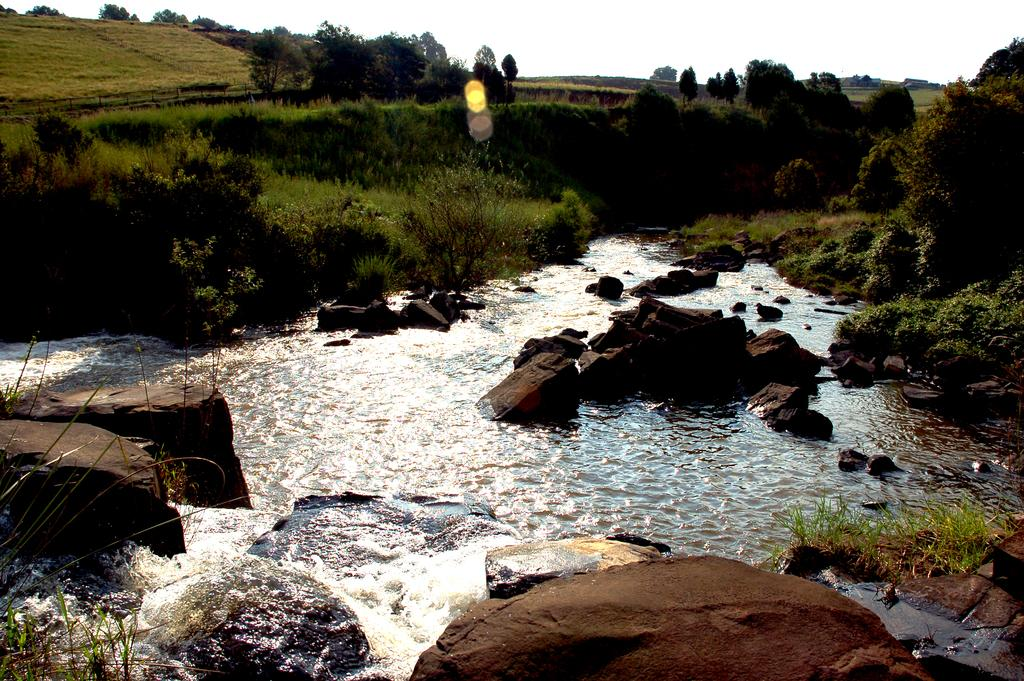What is in the foreground of the image? There is a water body in the foreground of the image. What is on the water body? There are stones on the water body. What can be seen in the background of the image? There are trees, plants, and grass in the background of the image. Where is the spot where the copy was made in the image? There is no mention of a spot or a copy in the image; it features a water body with stones and a background with trees, plants, and grass. What type of knot can be seen tied on the trees in the image? There are no knots visible on the trees in the image. 